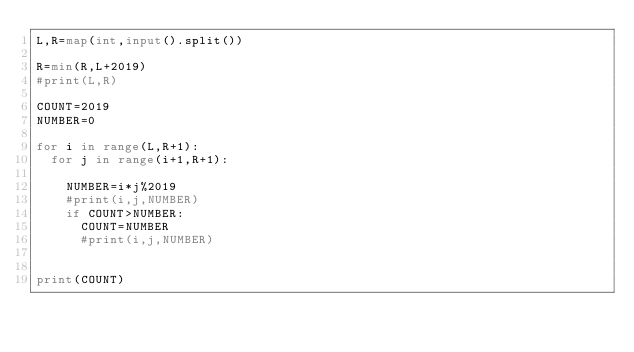<code> <loc_0><loc_0><loc_500><loc_500><_Python_>L,R=map(int,input().split())

R=min(R,L+2019)
#print(L,R)  
 
COUNT=2019
NUMBER=0
 
for i in range(L,R+1):
  for j in range(i+1,R+1):
    
    NUMBER=i*j%2019
    #print(i,j,NUMBER)
    if COUNT>NUMBER:
      COUNT=NUMBER
      #print(i,j,NUMBER)
 
    
print(COUNT)</code> 